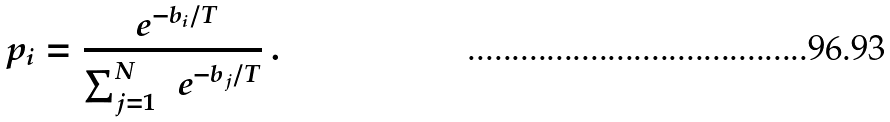<formula> <loc_0><loc_0><loc_500><loc_500>p _ { i } = \frac { { \ e } ^ { - b _ { i } / T } } { \sum _ { j = 1 } ^ { N } \, { \ e } ^ { - b _ { j } / T } } \, .</formula> 